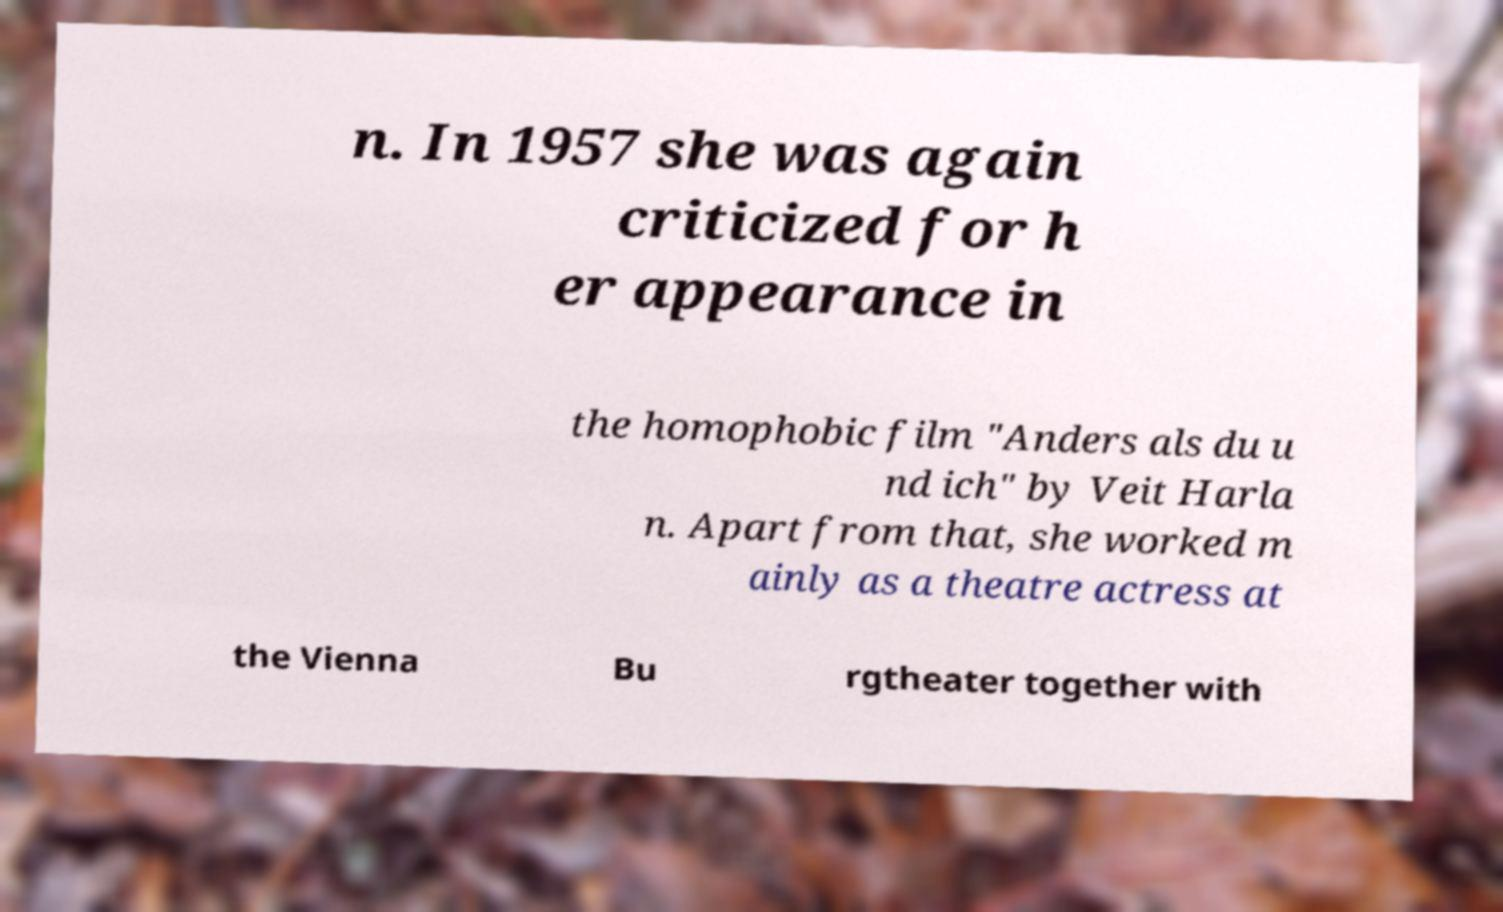Could you assist in decoding the text presented in this image and type it out clearly? n. In 1957 she was again criticized for h er appearance in the homophobic film "Anders als du u nd ich" by Veit Harla n. Apart from that, she worked m ainly as a theatre actress at the Vienna Bu rgtheater together with 